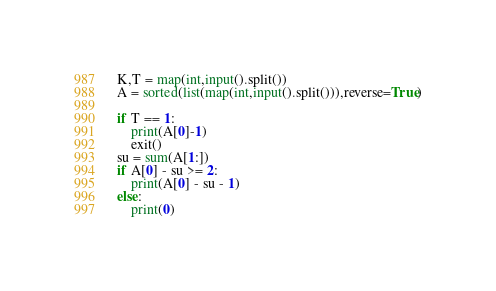Convert code to text. <code><loc_0><loc_0><loc_500><loc_500><_Python_>K,T = map(int,input().split())
A = sorted(list(map(int,input().split())),reverse=True)

if T == 1:
    print(A[0]-1)
    exit()
su = sum(A[1:])
if A[0] - su >= 2:
    print(A[0] - su - 1)
else:
    print(0)</code> 